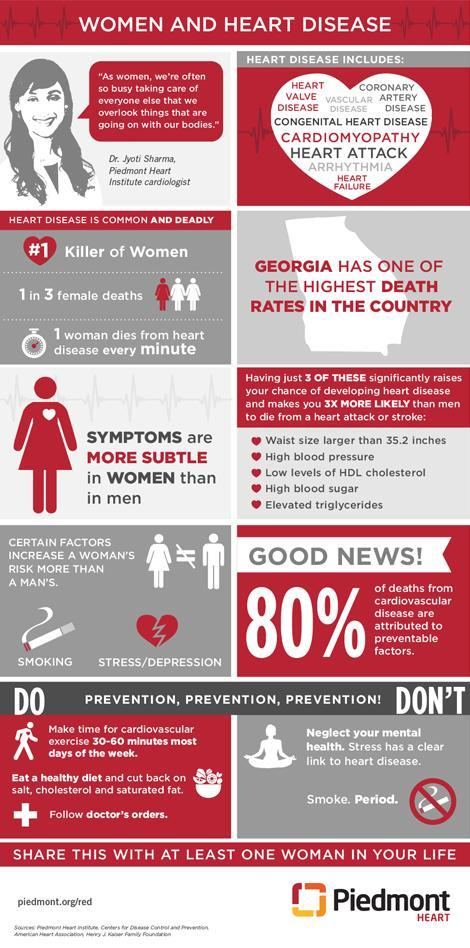Which is the most common form of heart disease?
Answer the question with a short phrase. Heart Attack 